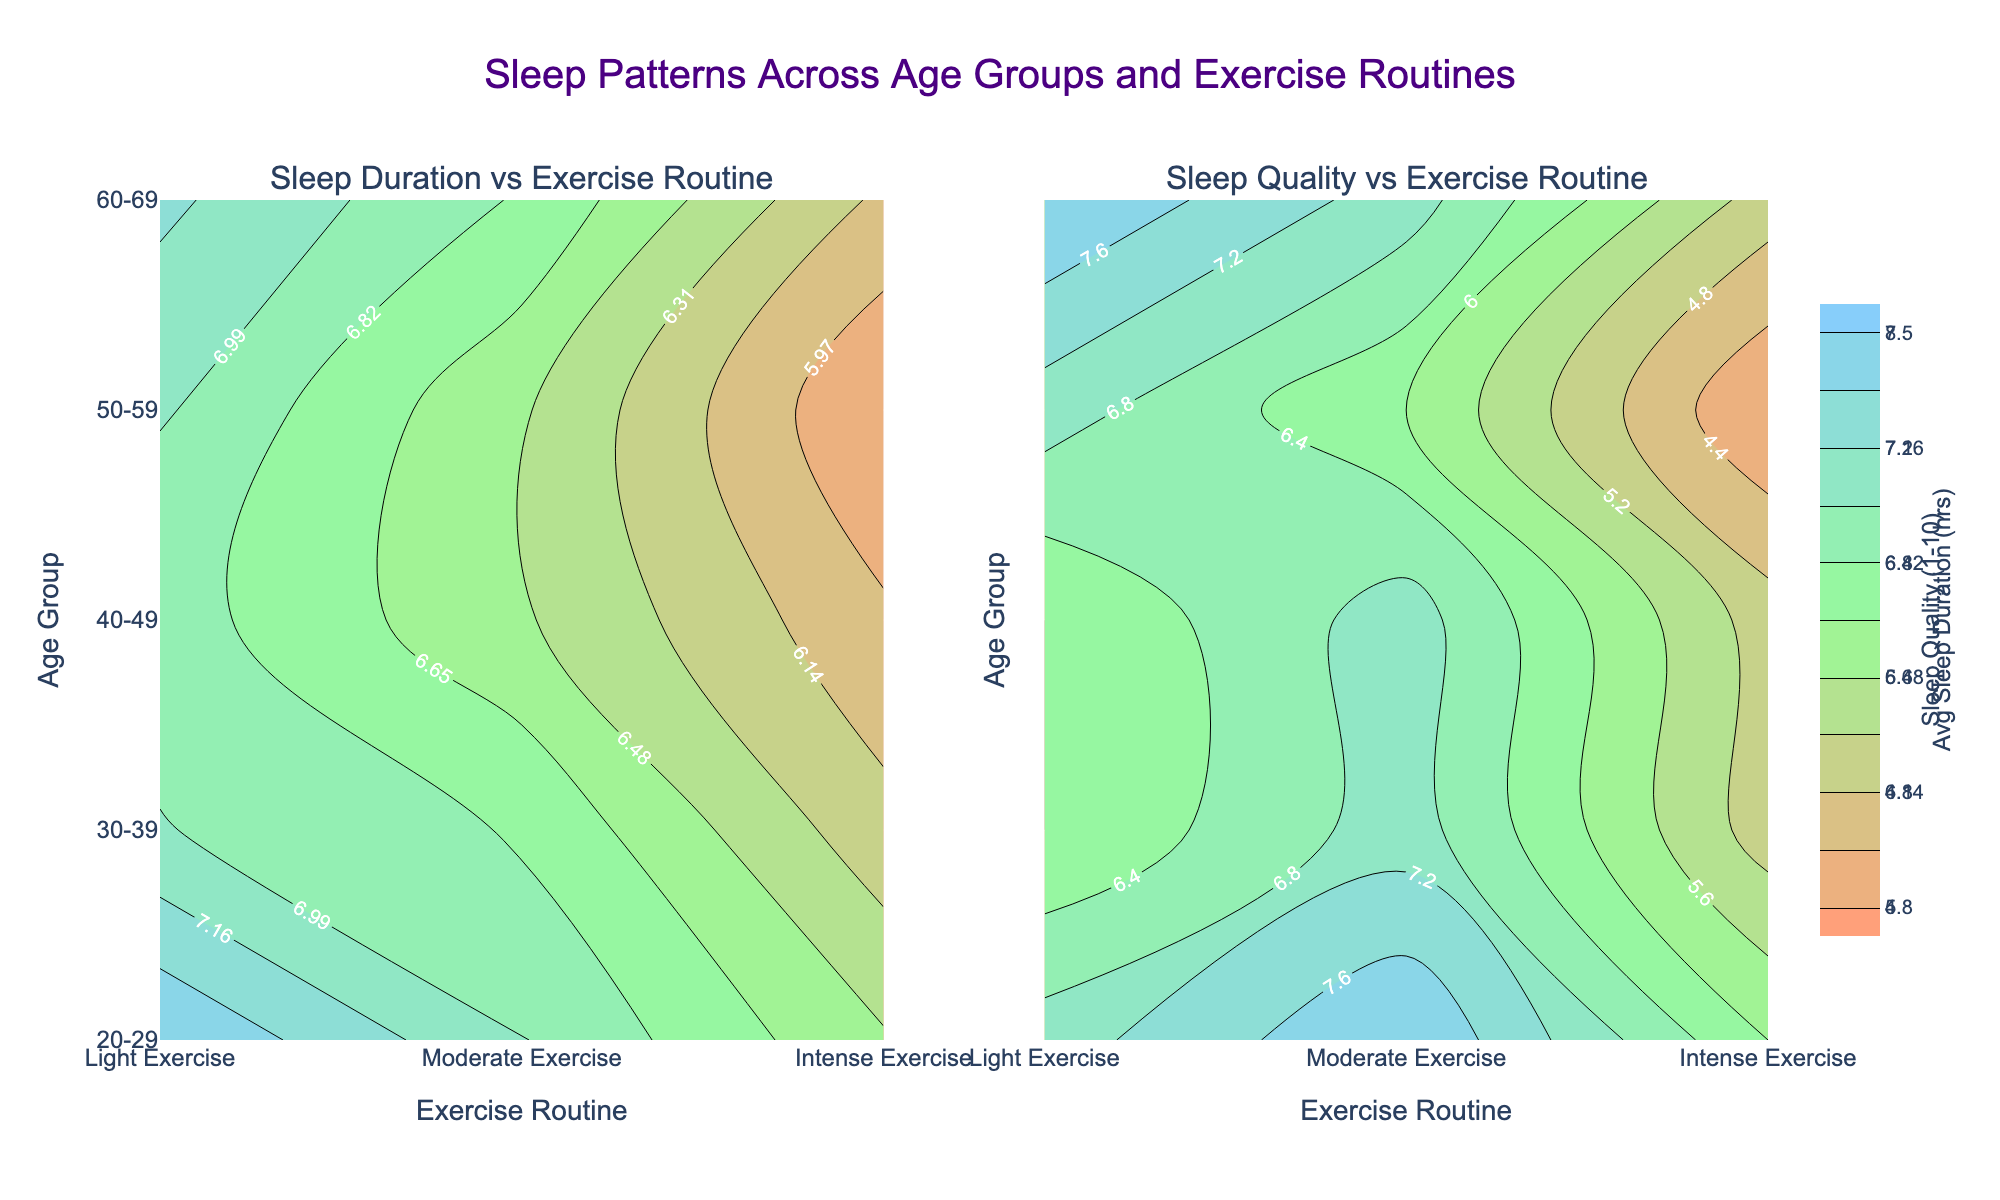What is the title of the figure? The title of the figure is centered at the top and reads "Sleep Patterns Across Age Groups and Exercise Routines".
Answer: Sleep Patterns Across Age Groups and Exercise Routines Which exercise routine corresponds to the highest sleep quality for the 20-29 age group? The contour plot on the right shows Sleep Quality versus Exercise Routine. For the 20-29 age group, the highest sleep quality (value 8) is associated with Moderate Exercise.
Answer: Moderate Exercise How does the average sleep duration change from Light Exercise to Intense Exercise for the 30-39 age group? The contour plot on the left shows Avg Sleep Duration versus Exercise Routine. For the 30-39 age group, the average sleep duration decreases from 7.0 hours (Light Exercise) to 6.2 hours (Intense Exercise).
Answer: It decreases from 7.0 to 6.2 hours Which age group shows the most significant drop in sleep quality when moving from Moderate to Intense Exercise? In the plot on the right, compare the Sleep Quality values for Moderate and Intense Exercise across all age groups. The 50-59 age group shows the most significant drop, from a Sleep Quality of 6 (Moderate) to 4 (Intense).
Answer: The 50-59 age group For the 60-69 age group, what is the difference in average sleep duration between Light Exercise and Moderate Exercise? Referring to the plot on the left, for the 60-69 age group, the average sleep duration for Light Exercise is 7.2 hours and for Moderate Exercise, it is 6.8 hours. The difference is 7.2 - 6.8 = 0.4 hours.
Answer: 0.4 hours Compare the sleep quality for the 40-49 age group under Moderate and Intense Exercise routines. Which one is higher? By looking at the contour plot on the right, for the 40-49 age group, the sleep quality under Moderate Exercise is 7 and under Intense Exercise is 5. The Moderate Exercise sleep quality is higher.
Answer: Moderate Exercise is higher Which age group consistently shows higher sleep quality with Light Exercise than with Intense Exercise? Review the sleep quality values from the contour plot on the right. The 20-29, 30-39, 40-49, 50-59, and 60-69 age groups all show higher sleep quality for Light Exercise compared to Intense Exercise.
Answer: All age groups What is the average sleep duration for the age group with the highest value under Light Exercise? The age group with the highest average sleep duration under Light Exercise is the 20-29 age group with 7.5 hours.
Answer: 7.5 hours If a person wants to maximize their sleep quality, which exercise routine should a 60-69-year-old choose? In the plot on the right, the highest sleep quality for the 60-69 age group is 8, which is associated with Light Exercise.
Answer: Light Exercise 